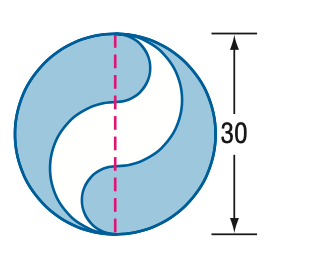Based on the image, directly select the correct answer for the following question:
Question: Find the area of the shaded region. Round to the nearest tenth.
Choices:
A: 392.7
B: 471.2
C: 589.0
D: 785.4 Answer:B 